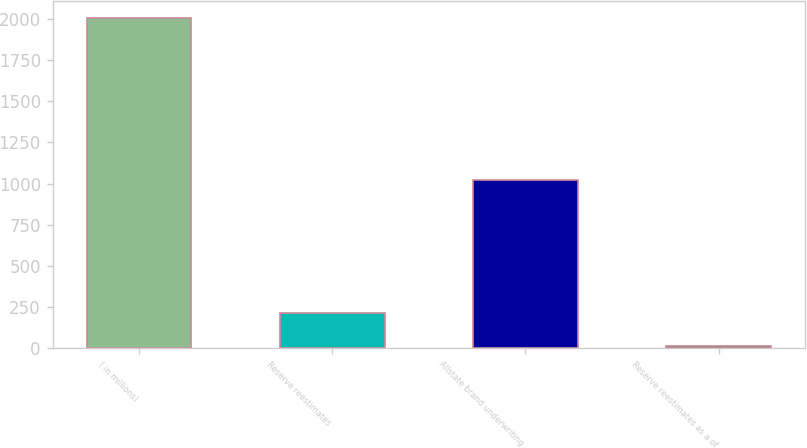<chart> <loc_0><loc_0><loc_500><loc_500><bar_chart><fcel>( in millions)<fcel>Reserve reestimates<fcel>Allstate brand underwriting<fcel>Reserve reestimates as a of<nl><fcel>2009<fcel>211.97<fcel>1022<fcel>12.3<nl></chart> 